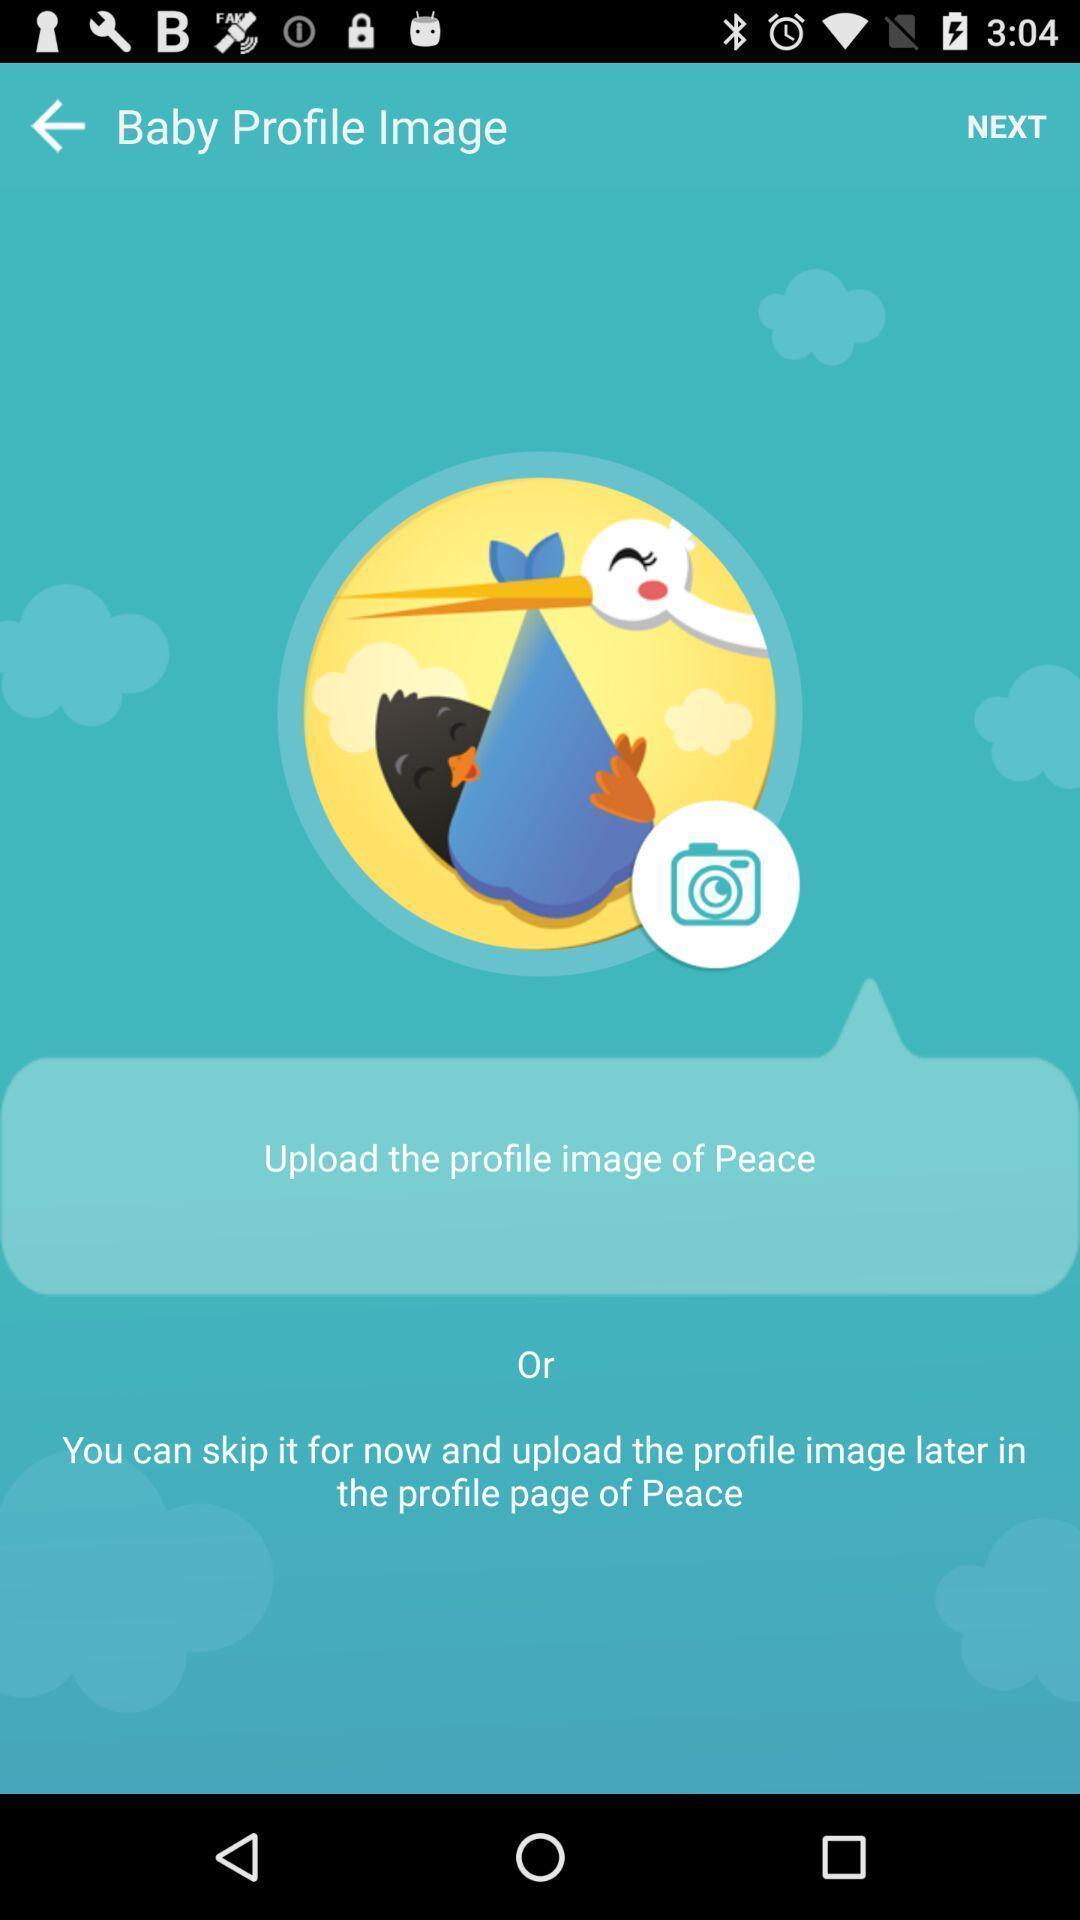Describe the visual elements of this screenshot. Page for uploading a profile picture on app. 